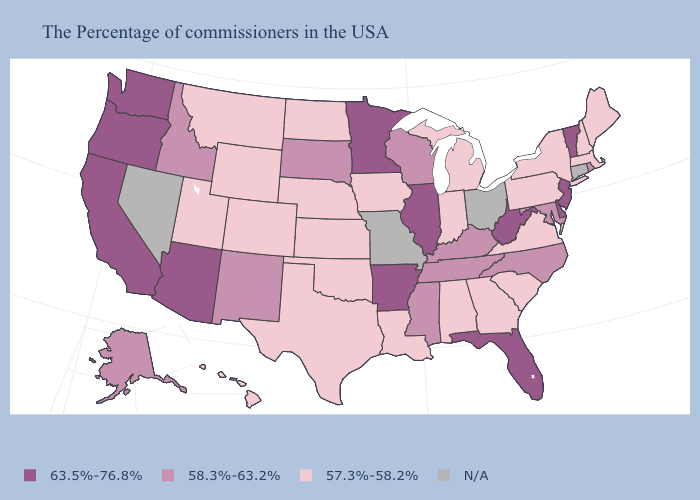What is the highest value in states that border Maryland?
Quick response, please. 63.5%-76.8%. Which states have the highest value in the USA?
Answer briefly. Vermont, New Jersey, Delaware, West Virginia, Florida, Illinois, Arkansas, Minnesota, Arizona, California, Washington, Oregon. What is the value of Virginia?
Answer briefly. 57.3%-58.2%. Which states have the highest value in the USA?
Answer briefly. Vermont, New Jersey, Delaware, West Virginia, Florida, Illinois, Arkansas, Minnesota, Arizona, California, Washington, Oregon. What is the value of Ohio?
Write a very short answer. N/A. What is the value of North Dakota?
Answer briefly. 57.3%-58.2%. Which states have the lowest value in the MidWest?
Keep it brief. Michigan, Indiana, Iowa, Kansas, Nebraska, North Dakota. Does North Dakota have the highest value in the MidWest?
Keep it brief. No. What is the highest value in the South ?
Concise answer only. 63.5%-76.8%. What is the value of Kansas?
Be succinct. 57.3%-58.2%. Is the legend a continuous bar?
Short answer required. No. How many symbols are there in the legend?
Concise answer only. 4. What is the value of New Mexico?
Give a very brief answer. 58.3%-63.2%. Among the states that border Florida , which have the highest value?
Concise answer only. Georgia, Alabama. 